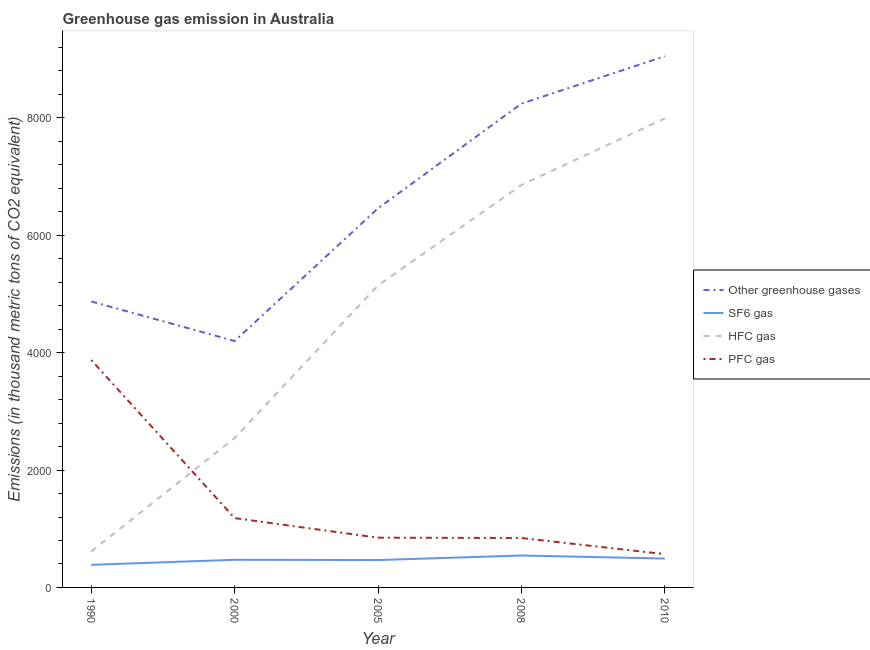Is the number of lines equal to the number of legend labels?
Ensure brevity in your answer.  Yes. What is the emission of greenhouse gases in 1990?
Your answer should be very brief. 4872.8. Across all years, what is the maximum emission of greenhouse gases?
Provide a succinct answer. 9051. Across all years, what is the minimum emission of greenhouse gases?
Provide a short and direct response. 4198.3. What is the total emission of greenhouse gases in the graph?
Your answer should be very brief. 3.28e+04. What is the difference between the emission of greenhouse gases in 1990 and that in 2008?
Your answer should be compact. -3370.7. What is the difference between the emission of sf6 gas in 2000 and the emission of pfc gas in 2010?
Provide a succinct answer. -95.8. What is the average emission of pfc gas per year?
Ensure brevity in your answer.  1462.6. In the year 2008, what is the difference between the emission of sf6 gas and emission of pfc gas?
Provide a short and direct response. -297.9. What is the ratio of the emission of greenhouse gases in 2008 to that in 2010?
Provide a succinct answer. 0.91. What is the difference between the highest and the second highest emission of sf6 gas?
Provide a succinct answer. 52.1. What is the difference between the highest and the lowest emission of hfc gas?
Ensure brevity in your answer.  7379.5. In how many years, is the emission of hfc gas greater than the average emission of hfc gas taken over all years?
Your answer should be compact. 3. Is it the case that in every year, the sum of the emission of greenhouse gases and emission of sf6 gas is greater than the sum of emission of hfc gas and emission of pfc gas?
Make the answer very short. No. Is it the case that in every year, the sum of the emission of greenhouse gases and emission of sf6 gas is greater than the emission of hfc gas?
Keep it short and to the point. Yes. How many lines are there?
Keep it short and to the point. 4. How many years are there in the graph?
Your answer should be very brief. 5. What is the difference between two consecutive major ticks on the Y-axis?
Give a very brief answer. 2000. Does the graph contain any zero values?
Your answer should be very brief. No. Does the graph contain grids?
Make the answer very short. No. What is the title of the graph?
Provide a succinct answer. Greenhouse gas emission in Australia. Does "Other greenhouse gases" appear as one of the legend labels in the graph?
Offer a very short reply. Yes. What is the label or title of the X-axis?
Provide a succinct answer. Year. What is the label or title of the Y-axis?
Provide a short and direct response. Emissions (in thousand metric tons of CO2 equivalent). What is the Emissions (in thousand metric tons of CO2 equivalent) in Other greenhouse gases in 1990?
Provide a succinct answer. 4872.8. What is the Emissions (in thousand metric tons of CO2 equivalent) of SF6 gas in 1990?
Provide a short and direct response. 385.1. What is the Emissions (in thousand metric tons of CO2 equivalent) of HFC gas in 1990?
Give a very brief answer. 612.5. What is the Emissions (in thousand metric tons of CO2 equivalent) of PFC gas in 1990?
Offer a very short reply. 3875.2. What is the Emissions (in thousand metric tons of CO2 equivalent) in Other greenhouse gases in 2000?
Give a very brief answer. 4198.3. What is the Emissions (in thousand metric tons of CO2 equivalent) of SF6 gas in 2000?
Ensure brevity in your answer.  471.2. What is the Emissions (in thousand metric tons of CO2 equivalent) in HFC gas in 2000?
Keep it short and to the point. 2545.7. What is the Emissions (in thousand metric tons of CO2 equivalent) in PFC gas in 2000?
Provide a short and direct response. 1181.4. What is the Emissions (in thousand metric tons of CO2 equivalent) of Other greenhouse gases in 2005?
Provide a succinct answer. 6459.6. What is the Emissions (in thousand metric tons of CO2 equivalent) of SF6 gas in 2005?
Offer a very short reply. 466.6. What is the Emissions (in thousand metric tons of CO2 equivalent) in HFC gas in 2005?
Ensure brevity in your answer.  5145.6. What is the Emissions (in thousand metric tons of CO2 equivalent) of PFC gas in 2005?
Ensure brevity in your answer.  847.4. What is the Emissions (in thousand metric tons of CO2 equivalent) of Other greenhouse gases in 2008?
Your answer should be compact. 8243.5. What is the Emissions (in thousand metric tons of CO2 equivalent) in SF6 gas in 2008?
Offer a terse response. 544.1. What is the Emissions (in thousand metric tons of CO2 equivalent) in HFC gas in 2008?
Ensure brevity in your answer.  6857.4. What is the Emissions (in thousand metric tons of CO2 equivalent) in PFC gas in 2008?
Provide a short and direct response. 842. What is the Emissions (in thousand metric tons of CO2 equivalent) of Other greenhouse gases in 2010?
Offer a terse response. 9051. What is the Emissions (in thousand metric tons of CO2 equivalent) of SF6 gas in 2010?
Keep it short and to the point. 492. What is the Emissions (in thousand metric tons of CO2 equivalent) of HFC gas in 2010?
Your answer should be very brief. 7992. What is the Emissions (in thousand metric tons of CO2 equivalent) of PFC gas in 2010?
Give a very brief answer. 567. Across all years, what is the maximum Emissions (in thousand metric tons of CO2 equivalent) in Other greenhouse gases?
Offer a very short reply. 9051. Across all years, what is the maximum Emissions (in thousand metric tons of CO2 equivalent) in SF6 gas?
Offer a very short reply. 544.1. Across all years, what is the maximum Emissions (in thousand metric tons of CO2 equivalent) of HFC gas?
Give a very brief answer. 7992. Across all years, what is the maximum Emissions (in thousand metric tons of CO2 equivalent) in PFC gas?
Provide a succinct answer. 3875.2. Across all years, what is the minimum Emissions (in thousand metric tons of CO2 equivalent) of Other greenhouse gases?
Make the answer very short. 4198.3. Across all years, what is the minimum Emissions (in thousand metric tons of CO2 equivalent) of SF6 gas?
Your response must be concise. 385.1. Across all years, what is the minimum Emissions (in thousand metric tons of CO2 equivalent) in HFC gas?
Provide a succinct answer. 612.5. Across all years, what is the minimum Emissions (in thousand metric tons of CO2 equivalent) of PFC gas?
Make the answer very short. 567. What is the total Emissions (in thousand metric tons of CO2 equivalent) in Other greenhouse gases in the graph?
Keep it short and to the point. 3.28e+04. What is the total Emissions (in thousand metric tons of CO2 equivalent) of SF6 gas in the graph?
Keep it short and to the point. 2359. What is the total Emissions (in thousand metric tons of CO2 equivalent) of HFC gas in the graph?
Keep it short and to the point. 2.32e+04. What is the total Emissions (in thousand metric tons of CO2 equivalent) of PFC gas in the graph?
Ensure brevity in your answer.  7313. What is the difference between the Emissions (in thousand metric tons of CO2 equivalent) of Other greenhouse gases in 1990 and that in 2000?
Give a very brief answer. 674.5. What is the difference between the Emissions (in thousand metric tons of CO2 equivalent) of SF6 gas in 1990 and that in 2000?
Provide a succinct answer. -86.1. What is the difference between the Emissions (in thousand metric tons of CO2 equivalent) in HFC gas in 1990 and that in 2000?
Give a very brief answer. -1933.2. What is the difference between the Emissions (in thousand metric tons of CO2 equivalent) in PFC gas in 1990 and that in 2000?
Your answer should be very brief. 2693.8. What is the difference between the Emissions (in thousand metric tons of CO2 equivalent) in Other greenhouse gases in 1990 and that in 2005?
Your response must be concise. -1586.8. What is the difference between the Emissions (in thousand metric tons of CO2 equivalent) of SF6 gas in 1990 and that in 2005?
Ensure brevity in your answer.  -81.5. What is the difference between the Emissions (in thousand metric tons of CO2 equivalent) of HFC gas in 1990 and that in 2005?
Give a very brief answer. -4533.1. What is the difference between the Emissions (in thousand metric tons of CO2 equivalent) of PFC gas in 1990 and that in 2005?
Ensure brevity in your answer.  3027.8. What is the difference between the Emissions (in thousand metric tons of CO2 equivalent) of Other greenhouse gases in 1990 and that in 2008?
Provide a short and direct response. -3370.7. What is the difference between the Emissions (in thousand metric tons of CO2 equivalent) in SF6 gas in 1990 and that in 2008?
Your answer should be very brief. -159. What is the difference between the Emissions (in thousand metric tons of CO2 equivalent) in HFC gas in 1990 and that in 2008?
Provide a succinct answer. -6244.9. What is the difference between the Emissions (in thousand metric tons of CO2 equivalent) in PFC gas in 1990 and that in 2008?
Ensure brevity in your answer.  3033.2. What is the difference between the Emissions (in thousand metric tons of CO2 equivalent) in Other greenhouse gases in 1990 and that in 2010?
Offer a terse response. -4178.2. What is the difference between the Emissions (in thousand metric tons of CO2 equivalent) in SF6 gas in 1990 and that in 2010?
Make the answer very short. -106.9. What is the difference between the Emissions (in thousand metric tons of CO2 equivalent) in HFC gas in 1990 and that in 2010?
Your response must be concise. -7379.5. What is the difference between the Emissions (in thousand metric tons of CO2 equivalent) of PFC gas in 1990 and that in 2010?
Give a very brief answer. 3308.2. What is the difference between the Emissions (in thousand metric tons of CO2 equivalent) of Other greenhouse gases in 2000 and that in 2005?
Your answer should be compact. -2261.3. What is the difference between the Emissions (in thousand metric tons of CO2 equivalent) in SF6 gas in 2000 and that in 2005?
Your answer should be compact. 4.6. What is the difference between the Emissions (in thousand metric tons of CO2 equivalent) of HFC gas in 2000 and that in 2005?
Provide a short and direct response. -2599.9. What is the difference between the Emissions (in thousand metric tons of CO2 equivalent) in PFC gas in 2000 and that in 2005?
Provide a succinct answer. 334. What is the difference between the Emissions (in thousand metric tons of CO2 equivalent) of Other greenhouse gases in 2000 and that in 2008?
Your response must be concise. -4045.2. What is the difference between the Emissions (in thousand metric tons of CO2 equivalent) of SF6 gas in 2000 and that in 2008?
Make the answer very short. -72.9. What is the difference between the Emissions (in thousand metric tons of CO2 equivalent) in HFC gas in 2000 and that in 2008?
Offer a terse response. -4311.7. What is the difference between the Emissions (in thousand metric tons of CO2 equivalent) of PFC gas in 2000 and that in 2008?
Provide a short and direct response. 339.4. What is the difference between the Emissions (in thousand metric tons of CO2 equivalent) of Other greenhouse gases in 2000 and that in 2010?
Ensure brevity in your answer.  -4852.7. What is the difference between the Emissions (in thousand metric tons of CO2 equivalent) of SF6 gas in 2000 and that in 2010?
Ensure brevity in your answer.  -20.8. What is the difference between the Emissions (in thousand metric tons of CO2 equivalent) in HFC gas in 2000 and that in 2010?
Offer a very short reply. -5446.3. What is the difference between the Emissions (in thousand metric tons of CO2 equivalent) of PFC gas in 2000 and that in 2010?
Your answer should be very brief. 614.4. What is the difference between the Emissions (in thousand metric tons of CO2 equivalent) in Other greenhouse gases in 2005 and that in 2008?
Provide a succinct answer. -1783.9. What is the difference between the Emissions (in thousand metric tons of CO2 equivalent) of SF6 gas in 2005 and that in 2008?
Offer a very short reply. -77.5. What is the difference between the Emissions (in thousand metric tons of CO2 equivalent) in HFC gas in 2005 and that in 2008?
Offer a terse response. -1711.8. What is the difference between the Emissions (in thousand metric tons of CO2 equivalent) of Other greenhouse gases in 2005 and that in 2010?
Ensure brevity in your answer.  -2591.4. What is the difference between the Emissions (in thousand metric tons of CO2 equivalent) of SF6 gas in 2005 and that in 2010?
Provide a short and direct response. -25.4. What is the difference between the Emissions (in thousand metric tons of CO2 equivalent) in HFC gas in 2005 and that in 2010?
Make the answer very short. -2846.4. What is the difference between the Emissions (in thousand metric tons of CO2 equivalent) in PFC gas in 2005 and that in 2010?
Give a very brief answer. 280.4. What is the difference between the Emissions (in thousand metric tons of CO2 equivalent) of Other greenhouse gases in 2008 and that in 2010?
Provide a succinct answer. -807.5. What is the difference between the Emissions (in thousand metric tons of CO2 equivalent) of SF6 gas in 2008 and that in 2010?
Offer a terse response. 52.1. What is the difference between the Emissions (in thousand metric tons of CO2 equivalent) of HFC gas in 2008 and that in 2010?
Offer a terse response. -1134.6. What is the difference between the Emissions (in thousand metric tons of CO2 equivalent) of PFC gas in 2008 and that in 2010?
Provide a succinct answer. 275. What is the difference between the Emissions (in thousand metric tons of CO2 equivalent) in Other greenhouse gases in 1990 and the Emissions (in thousand metric tons of CO2 equivalent) in SF6 gas in 2000?
Your answer should be very brief. 4401.6. What is the difference between the Emissions (in thousand metric tons of CO2 equivalent) in Other greenhouse gases in 1990 and the Emissions (in thousand metric tons of CO2 equivalent) in HFC gas in 2000?
Provide a short and direct response. 2327.1. What is the difference between the Emissions (in thousand metric tons of CO2 equivalent) of Other greenhouse gases in 1990 and the Emissions (in thousand metric tons of CO2 equivalent) of PFC gas in 2000?
Offer a terse response. 3691.4. What is the difference between the Emissions (in thousand metric tons of CO2 equivalent) of SF6 gas in 1990 and the Emissions (in thousand metric tons of CO2 equivalent) of HFC gas in 2000?
Ensure brevity in your answer.  -2160.6. What is the difference between the Emissions (in thousand metric tons of CO2 equivalent) in SF6 gas in 1990 and the Emissions (in thousand metric tons of CO2 equivalent) in PFC gas in 2000?
Give a very brief answer. -796.3. What is the difference between the Emissions (in thousand metric tons of CO2 equivalent) of HFC gas in 1990 and the Emissions (in thousand metric tons of CO2 equivalent) of PFC gas in 2000?
Provide a succinct answer. -568.9. What is the difference between the Emissions (in thousand metric tons of CO2 equivalent) in Other greenhouse gases in 1990 and the Emissions (in thousand metric tons of CO2 equivalent) in SF6 gas in 2005?
Keep it short and to the point. 4406.2. What is the difference between the Emissions (in thousand metric tons of CO2 equivalent) in Other greenhouse gases in 1990 and the Emissions (in thousand metric tons of CO2 equivalent) in HFC gas in 2005?
Give a very brief answer. -272.8. What is the difference between the Emissions (in thousand metric tons of CO2 equivalent) in Other greenhouse gases in 1990 and the Emissions (in thousand metric tons of CO2 equivalent) in PFC gas in 2005?
Your answer should be compact. 4025.4. What is the difference between the Emissions (in thousand metric tons of CO2 equivalent) in SF6 gas in 1990 and the Emissions (in thousand metric tons of CO2 equivalent) in HFC gas in 2005?
Your answer should be compact. -4760.5. What is the difference between the Emissions (in thousand metric tons of CO2 equivalent) in SF6 gas in 1990 and the Emissions (in thousand metric tons of CO2 equivalent) in PFC gas in 2005?
Offer a terse response. -462.3. What is the difference between the Emissions (in thousand metric tons of CO2 equivalent) of HFC gas in 1990 and the Emissions (in thousand metric tons of CO2 equivalent) of PFC gas in 2005?
Make the answer very short. -234.9. What is the difference between the Emissions (in thousand metric tons of CO2 equivalent) of Other greenhouse gases in 1990 and the Emissions (in thousand metric tons of CO2 equivalent) of SF6 gas in 2008?
Your answer should be compact. 4328.7. What is the difference between the Emissions (in thousand metric tons of CO2 equivalent) in Other greenhouse gases in 1990 and the Emissions (in thousand metric tons of CO2 equivalent) in HFC gas in 2008?
Offer a very short reply. -1984.6. What is the difference between the Emissions (in thousand metric tons of CO2 equivalent) of Other greenhouse gases in 1990 and the Emissions (in thousand metric tons of CO2 equivalent) of PFC gas in 2008?
Your answer should be compact. 4030.8. What is the difference between the Emissions (in thousand metric tons of CO2 equivalent) in SF6 gas in 1990 and the Emissions (in thousand metric tons of CO2 equivalent) in HFC gas in 2008?
Keep it short and to the point. -6472.3. What is the difference between the Emissions (in thousand metric tons of CO2 equivalent) of SF6 gas in 1990 and the Emissions (in thousand metric tons of CO2 equivalent) of PFC gas in 2008?
Provide a succinct answer. -456.9. What is the difference between the Emissions (in thousand metric tons of CO2 equivalent) of HFC gas in 1990 and the Emissions (in thousand metric tons of CO2 equivalent) of PFC gas in 2008?
Provide a short and direct response. -229.5. What is the difference between the Emissions (in thousand metric tons of CO2 equivalent) in Other greenhouse gases in 1990 and the Emissions (in thousand metric tons of CO2 equivalent) in SF6 gas in 2010?
Give a very brief answer. 4380.8. What is the difference between the Emissions (in thousand metric tons of CO2 equivalent) of Other greenhouse gases in 1990 and the Emissions (in thousand metric tons of CO2 equivalent) of HFC gas in 2010?
Offer a very short reply. -3119.2. What is the difference between the Emissions (in thousand metric tons of CO2 equivalent) in Other greenhouse gases in 1990 and the Emissions (in thousand metric tons of CO2 equivalent) in PFC gas in 2010?
Make the answer very short. 4305.8. What is the difference between the Emissions (in thousand metric tons of CO2 equivalent) in SF6 gas in 1990 and the Emissions (in thousand metric tons of CO2 equivalent) in HFC gas in 2010?
Give a very brief answer. -7606.9. What is the difference between the Emissions (in thousand metric tons of CO2 equivalent) in SF6 gas in 1990 and the Emissions (in thousand metric tons of CO2 equivalent) in PFC gas in 2010?
Make the answer very short. -181.9. What is the difference between the Emissions (in thousand metric tons of CO2 equivalent) in HFC gas in 1990 and the Emissions (in thousand metric tons of CO2 equivalent) in PFC gas in 2010?
Your answer should be compact. 45.5. What is the difference between the Emissions (in thousand metric tons of CO2 equivalent) of Other greenhouse gases in 2000 and the Emissions (in thousand metric tons of CO2 equivalent) of SF6 gas in 2005?
Your response must be concise. 3731.7. What is the difference between the Emissions (in thousand metric tons of CO2 equivalent) of Other greenhouse gases in 2000 and the Emissions (in thousand metric tons of CO2 equivalent) of HFC gas in 2005?
Provide a short and direct response. -947.3. What is the difference between the Emissions (in thousand metric tons of CO2 equivalent) of Other greenhouse gases in 2000 and the Emissions (in thousand metric tons of CO2 equivalent) of PFC gas in 2005?
Provide a short and direct response. 3350.9. What is the difference between the Emissions (in thousand metric tons of CO2 equivalent) of SF6 gas in 2000 and the Emissions (in thousand metric tons of CO2 equivalent) of HFC gas in 2005?
Provide a short and direct response. -4674.4. What is the difference between the Emissions (in thousand metric tons of CO2 equivalent) in SF6 gas in 2000 and the Emissions (in thousand metric tons of CO2 equivalent) in PFC gas in 2005?
Ensure brevity in your answer.  -376.2. What is the difference between the Emissions (in thousand metric tons of CO2 equivalent) of HFC gas in 2000 and the Emissions (in thousand metric tons of CO2 equivalent) of PFC gas in 2005?
Provide a succinct answer. 1698.3. What is the difference between the Emissions (in thousand metric tons of CO2 equivalent) of Other greenhouse gases in 2000 and the Emissions (in thousand metric tons of CO2 equivalent) of SF6 gas in 2008?
Your answer should be very brief. 3654.2. What is the difference between the Emissions (in thousand metric tons of CO2 equivalent) in Other greenhouse gases in 2000 and the Emissions (in thousand metric tons of CO2 equivalent) in HFC gas in 2008?
Offer a terse response. -2659.1. What is the difference between the Emissions (in thousand metric tons of CO2 equivalent) of Other greenhouse gases in 2000 and the Emissions (in thousand metric tons of CO2 equivalent) of PFC gas in 2008?
Make the answer very short. 3356.3. What is the difference between the Emissions (in thousand metric tons of CO2 equivalent) of SF6 gas in 2000 and the Emissions (in thousand metric tons of CO2 equivalent) of HFC gas in 2008?
Your answer should be compact. -6386.2. What is the difference between the Emissions (in thousand metric tons of CO2 equivalent) in SF6 gas in 2000 and the Emissions (in thousand metric tons of CO2 equivalent) in PFC gas in 2008?
Provide a succinct answer. -370.8. What is the difference between the Emissions (in thousand metric tons of CO2 equivalent) of HFC gas in 2000 and the Emissions (in thousand metric tons of CO2 equivalent) of PFC gas in 2008?
Offer a terse response. 1703.7. What is the difference between the Emissions (in thousand metric tons of CO2 equivalent) of Other greenhouse gases in 2000 and the Emissions (in thousand metric tons of CO2 equivalent) of SF6 gas in 2010?
Provide a short and direct response. 3706.3. What is the difference between the Emissions (in thousand metric tons of CO2 equivalent) in Other greenhouse gases in 2000 and the Emissions (in thousand metric tons of CO2 equivalent) in HFC gas in 2010?
Your response must be concise. -3793.7. What is the difference between the Emissions (in thousand metric tons of CO2 equivalent) of Other greenhouse gases in 2000 and the Emissions (in thousand metric tons of CO2 equivalent) of PFC gas in 2010?
Your answer should be very brief. 3631.3. What is the difference between the Emissions (in thousand metric tons of CO2 equivalent) in SF6 gas in 2000 and the Emissions (in thousand metric tons of CO2 equivalent) in HFC gas in 2010?
Your answer should be compact. -7520.8. What is the difference between the Emissions (in thousand metric tons of CO2 equivalent) of SF6 gas in 2000 and the Emissions (in thousand metric tons of CO2 equivalent) of PFC gas in 2010?
Offer a very short reply. -95.8. What is the difference between the Emissions (in thousand metric tons of CO2 equivalent) in HFC gas in 2000 and the Emissions (in thousand metric tons of CO2 equivalent) in PFC gas in 2010?
Provide a succinct answer. 1978.7. What is the difference between the Emissions (in thousand metric tons of CO2 equivalent) of Other greenhouse gases in 2005 and the Emissions (in thousand metric tons of CO2 equivalent) of SF6 gas in 2008?
Give a very brief answer. 5915.5. What is the difference between the Emissions (in thousand metric tons of CO2 equivalent) of Other greenhouse gases in 2005 and the Emissions (in thousand metric tons of CO2 equivalent) of HFC gas in 2008?
Provide a succinct answer. -397.8. What is the difference between the Emissions (in thousand metric tons of CO2 equivalent) in Other greenhouse gases in 2005 and the Emissions (in thousand metric tons of CO2 equivalent) in PFC gas in 2008?
Provide a succinct answer. 5617.6. What is the difference between the Emissions (in thousand metric tons of CO2 equivalent) of SF6 gas in 2005 and the Emissions (in thousand metric tons of CO2 equivalent) of HFC gas in 2008?
Your answer should be very brief. -6390.8. What is the difference between the Emissions (in thousand metric tons of CO2 equivalent) of SF6 gas in 2005 and the Emissions (in thousand metric tons of CO2 equivalent) of PFC gas in 2008?
Keep it short and to the point. -375.4. What is the difference between the Emissions (in thousand metric tons of CO2 equivalent) in HFC gas in 2005 and the Emissions (in thousand metric tons of CO2 equivalent) in PFC gas in 2008?
Your response must be concise. 4303.6. What is the difference between the Emissions (in thousand metric tons of CO2 equivalent) in Other greenhouse gases in 2005 and the Emissions (in thousand metric tons of CO2 equivalent) in SF6 gas in 2010?
Provide a short and direct response. 5967.6. What is the difference between the Emissions (in thousand metric tons of CO2 equivalent) of Other greenhouse gases in 2005 and the Emissions (in thousand metric tons of CO2 equivalent) of HFC gas in 2010?
Your answer should be compact. -1532.4. What is the difference between the Emissions (in thousand metric tons of CO2 equivalent) in Other greenhouse gases in 2005 and the Emissions (in thousand metric tons of CO2 equivalent) in PFC gas in 2010?
Make the answer very short. 5892.6. What is the difference between the Emissions (in thousand metric tons of CO2 equivalent) of SF6 gas in 2005 and the Emissions (in thousand metric tons of CO2 equivalent) of HFC gas in 2010?
Your response must be concise. -7525.4. What is the difference between the Emissions (in thousand metric tons of CO2 equivalent) of SF6 gas in 2005 and the Emissions (in thousand metric tons of CO2 equivalent) of PFC gas in 2010?
Provide a succinct answer. -100.4. What is the difference between the Emissions (in thousand metric tons of CO2 equivalent) of HFC gas in 2005 and the Emissions (in thousand metric tons of CO2 equivalent) of PFC gas in 2010?
Provide a short and direct response. 4578.6. What is the difference between the Emissions (in thousand metric tons of CO2 equivalent) in Other greenhouse gases in 2008 and the Emissions (in thousand metric tons of CO2 equivalent) in SF6 gas in 2010?
Offer a terse response. 7751.5. What is the difference between the Emissions (in thousand metric tons of CO2 equivalent) in Other greenhouse gases in 2008 and the Emissions (in thousand metric tons of CO2 equivalent) in HFC gas in 2010?
Offer a terse response. 251.5. What is the difference between the Emissions (in thousand metric tons of CO2 equivalent) of Other greenhouse gases in 2008 and the Emissions (in thousand metric tons of CO2 equivalent) of PFC gas in 2010?
Offer a very short reply. 7676.5. What is the difference between the Emissions (in thousand metric tons of CO2 equivalent) in SF6 gas in 2008 and the Emissions (in thousand metric tons of CO2 equivalent) in HFC gas in 2010?
Your answer should be compact. -7447.9. What is the difference between the Emissions (in thousand metric tons of CO2 equivalent) in SF6 gas in 2008 and the Emissions (in thousand metric tons of CO2 equivalent) in PFC gas in 2010?
Provide a short and direct response. -22.9. What is the difference between the Emissions (in thousand metric tons of CO2 equivalent) in HFC gas in 2008 and the Emissions (in thousand metric tons of CO2 equivalent) in PFC gas in 2010?
Provide a succinct answer. 6290.4. What is the average Emissions (in thousand metric tons of CO2 equivalent) in Other greenhouse gases per year?
Make the answer very short. 6565.04. What is the average Emissions (in thousand metric tons of CO2 equivalent) in SF6 gas per year?
Your answer should be very brief. 471.8. What is the average Emissions (in thousand metric tons of CO2 equivalent) in HFC gas per year?
Give a very brief answer. 4630.64. What is the average Emissions (in thousand metric tons of CO2 equivalent) of PFC gas per year?
Provide a succinct answer. 1462.6. In the year 1990, what is the difference between the Emissions (in thousand metric tons of CO2 equivalent) of Other greenhouse gases and Emissions (in thousand metric tons of CO2 equivalent) of SF6 gas?
Your answer should be very brief. 4487.7. In the year 1990, what is the difference between the Emissions (in thousand metric tons of CO2 equivalent) in Other greenhouse gases and Emissions (in thousand metric tons of CO2 equivalent) in HFC gas?
Make the answer very short. 4260.3. In the year 1990, what is the difference between the Emissions (in thousand metric tons of CO2 equivalent) in Other greenhouse gases and Emissions (in thousand metric tons of CO2 equivalent) in PFC gas?
Offer a very short reply. 997.6. In the year 1990, what is the difference between the Emissions (in thousand metric tons of CO2 equivalent) in SF6 gas and Emissions (in thousand metric tons of CO2 equivalent) in HFC gas?
Make the answer very short. -227.4. In the year 1990, what is the difference between the Emissions (in thousand metric tons of CO2 equivalent) in SF6 gas and Emissions (in thousand metric tons of CO2 equivalent) in PFC gas?
Your answer should be compact. -3490.1. In the year 1990, what is the difference between the Emissions (in thousand metric tons of CO2 equivalent) in HFC gas and Emissions (in thousand metric tons of CO2 equivalent) in PFC gas?
Offer a terse response. -3262.7. In the year 2000, what is the difference between the Emissions (in thousand metric tons of CO2 equivalent) in Other greenhouse gases and Emissions (in thousand metric tons of CO2 equivalent) in SF6 gas?
Offer a terse response. 3727.1. In the year 2000, what is the difference between the Emissions (in thousand metric tons of CO2 equivalent) in Other greenhouse gases and Emissions (in thousand metric tons of CO2 equivalent) in HFC gas?
Offer a terse response. 1652.6. In the year 2000, what is the difference between the Emissions (in thousand metric tons of CO2 equivalent) of Other greenhouse gases and Emissions (in thousand metric tons of CO2 equivalent) of PFC gas?
Make the answer very short. 3016.9. In the year 2000, what is the difference between the Emissions (in thousand metric tons of CO2 equivalent) of SF6 gas and Emissions (in thousand metric tons of CO2 equivalent) of HFC gas?
Provide a short and direct response. -2074.5. In the year 2000, what is the difference between the Emissions (in thousand metric tons of CO2 equivalent) in SF6 gas and Emissions (in thousand metric tons of CO2 equivalent) in PFC gas?
Give a very brief answer. -710.2. In the year 2000, what is the difference between the Emissions (in thousand metric tons of CO2 equivalent) in HFC gas and Emissions (in thousand metric tons of CO2 equivalent) in PFC gas?
Offer a terse response. 1364.3. In the year 2005, what is the difference between the Emissions (in thousand metric tons of CO2 equivalent) in Other greenhouse gases and Emissions (in thousand metric tons of CO2 equivalent) in SF6 gas?
Your answer should be compact. 5993. In the year 2005, what is the difference between the Emissions (in thousand metric tons of CO2 equivalent) of Other greenhouse gases and Emissions (in thousand metric tons of CO2 equivalent) of HFC gas?
Your response must be concise. 1314. In the year 2005, what is the difference between the Emissions (in thousand metric tons of CO2 equivalent) in Other greenhouse gases and Emissions (in thousand metric tons of CO2 equivalent) in PFC gas?
Offer a very short reply. 5612.2. In the year 2005, what is the difference between the Emissions (in thousand metric tons of CO2 equivalent) of SF6 gas and Emissions (in thousand metric tons of CO2 equivalent) of HFC gas?
Ensure brevity in your answer.  -4679. In the year 2005, what is the difference between the Emissions (in thousand metric tons of CO2 equivalent) in SF6 gas and Emissions (in thousand metric tons of CO2 equivalent) in PFC gas?
Keep it short and to the point. -380.8. In the year 2005, what is the difference between the Emissions (in thousand metric tons of CO2 equivalent) in HFC gas and Emissions (in thousand metric tons of CO2 equivalent) in PFC gas?
Provide a short and direct response. 4298.2. In the year 2008, what is the difference between the Emissions (in thousand metric tons of CO2 equivalent) in Other greenhouse gases and Emissions (in thousand metric tons of CO2 equivalent) in SF6 gas?
Keep it short and to the point. 7699.4. In the year 2008, what is the difference between the Emissions (in thousand metric tons of CO2 equivalent) of Other greenhouse gases and Emissions (in thousand metric tons of CO2 equivalent) of HFC gas?
Your answer should be compact. 1386.1. In the year 2008, what is the difference between the Emissions (in thousand metric tons of CO2 equivalent) in Other greenhouse gases and Emissions (in thousand metric tons of CO2 equivalent) in PFC gas?
Provide a short and direct response. 7401.5. In the year 2008, what is the difference between the Emissions (in thousand metric tons of CO2 equivalent) of SF6 gas and Emissions (in thousand metric tons of CO2 equivalent) of HFC gas?
Ensure brevity in your answer.  -6313.3. In the year 2008, what is the difference between the Emissions (in thousand metric tons of CO2 equivalent) of SF6 gas and Emissions (in thousand metric tons of CO2 equivalent) of PFC gas?
Provide a short and direct response. -297.9. In the year 2008, what is the difference between the Emissions (in thousand metric tons of CO2 equivalent) in HFC gas and Emissions (in thousand metric tons of CO2 equivalent) in PFC gas?
Provide a succinct answer. 6015.4. In the year 2010, what is the difference between the Emissions (in thousand metric tons of CO2 equivalent) of Other greenhouse gases and Emissions (in thousand metric tons of CO2 equivalent) of SF6 gas?
Provide a short and direct response. 8559. In the year 2010, what is the difference between the Emissions (in thousand metric tons of CO2 equivalent) in Other greenhouse gases and Emissions (in thousand metric tons of CO2 equivalent) in HFC gas?
Give a very brief answer. 1059. In the year 2010, what is the difference between the Emissions (in thousand metric tons of CO2 equivalent) in Other greenhouse gases and Emissions (in thousand metric tons of CO2 equivalent) in PFC gas?
Give a very brief answer. 8484. In the year 2010, what is the difference between the Emissions (in thousand metric tons of CO2 equivalent) of SF6 gas and Emissions (in thousand metric tons of CO2 equivalent) of HFC gas?
Provide a succinct answer. -7500. In the year 2010, what is the difference between the Emissions (in thousand metric tons of CO2 equivalent) in SF6 gas and Emissions (in thousand metric tons of CO2 equivalent) in PFC gas?
Offer a terse response. -75. In the year 2010, what is the difference between the Emissions (in thousand metric tons of CO2 equivalent) of HFC gas and Emissions (in thousand metric tons of CO2 equivalent) of PFC gas?
Your response must be concise. 7425. What is the ratio of the Emissions (in thousand metric tons of CO2 equivalent) in Other greenhouse gases in 1990 to that in 2000?
Provide a short and direct response. 1.16. What is the ratio of the Emissions (in thousand metric tons of CO2 equivalent) in SF6 gas in 1990 to that in 2000?
Make the answer very short. 0.82. What is the ratio of the Emissions (in thousand metric tons of CO2 equivalent) of HFC gas in 1990 to that in 2000?
Give a very brief answer. 0.24. What is the ratio of the Emissions (in thousand metric tons of CO2 equivalent) of PFC gas in 1990 to that in 2000?
Your response must be concise. 3.28. What is the ratio of the Emissions (in thousand metric tons of CO2 equivalent) in Other greenhouse gases in 1990 to that in 2005?
Keep it short and to the point. 0.75. What is the ratio of the Emissions (in thousand metric tons of CO2 equivalent) of SF6 gas in 1990 to that in 2005?
Make the answer very short. 0.83. What is the ratio of the Emissions (in thousand metric tons of CO2 equivalent) of HFC gas in 1990 to that in 2005?
Provide a short and direct response. 0.12. What is the ratio of the Emissions (in thousand metric tons of CO2 equivalent) of PFC gas in 1990 to that in 2005?
Your answer should be compact. 4.57. What is the ratio of the Emissions (in thousand metric tons of CO2 equivalent) in Other greenhouse gases in 1990 to that in 2008?
Keep it short and to the point. 0.59. What is the ratio of the Emissions (in thousand metric tons of CO2 equivalent) in SF6 gas in 1990 to that in 2008?
Your answer should be compact. 0.71. What is the ratio of the Emissions (in thousand metric tons of CO2 equivalent) in HFC gas in 1990 to that in 2008?
Offer a very short reply. 0.09. What is the ratio of the Emissions (in thousand metric tons of CO2 equivalent) of PFC gas in 1990 to that in 2008?
Keep it short and to the point. 4.6. What is the ratio of the Emissions (in thousand metric tons of CO2 equivalent) of Other greenhouse gases in 1990 to that in 2010?
Make the answer very short. 0.54. What is the ratio of the Emissions (in thousand metric tons of CO2 equivalent) of SF6 gas in 1990 to that in 2010?
Ensure brevity in your answer.  0.78. What is the ratio of the Emissions (in thousand metric tons of CO2 equivalent) of HFC gas in 1990 to that in 2010?
Your answer should be very brief. 0.08. What is the ratio of the Emissions (in thousand metric tons of CO2 equivalent) in PFC gas in 1990 to that in 2010?
Provide a succinct answer. 6.83. What is the ratio of the Emissions (in thousand metric tons of CO2 equivalent) of Other greenhouse gases in 2000 to that in 2005?
Give a very brief answer. 0.65. What is the ratio of the Emissions (in thousand metric tons of CO2 equivalent) in SF6 gas in 2000 to that in 2005?
Your answer should be very brief. 1.01. What is the ratio of the Emissions (in thousand metric tons of CO2 equivalent) in HFC gas in 2000 to that in 2005?
Your answer should be compact. 0.49. What is the ratio of the Emissions (in thousand metric tons of CO2 equivalent) of PFC gas in 2000 to that in 2005?
Ensure brevity in your answer.  1.39. What is the ratio of the Emissions (in thousand metric tons of CO2 equivalent) of Other greenhouse gases in 2000 to that in 2008?
Your answer should be very brief. 0.51. What is the ratio of the Emissions (in thousand metric tons of CO2 equivalent) of SF6 gas in 2000 to that in 2008?
Make the answer very short. 0.87. What is the ratio of the Emissions (in thousand metric tons of CO2 equivalent) of HFC gas in 2000 to that in 2008?
Offer a terse response. 0.37. What is the ratio of the Emissions (in thousand metric tons of CO2 equivalent) of PFC gas in 2000 to that in 2008?
Provide a short and direct response. 1.4. What is the ratio of the Emissions (in thousand metric tons of CO2 equivalent) in Other greenhouse gases in 2000 to that in 2010?
Your answer should be very brief. 0.46. What is the ratio of the Emissions (in thousand metric tons of CO2 equivalent) of SF6 gas in 2000 to that in 2010?
Make the answer very short. 0.96. What is the ratio of the Emissions (in thousand metric tons of CO2 equivalent) in HFC gas in 2000 to that in 2010?
Make the answer very short. 0.32. What is the ratio of the Emissions (in thousand metric tons of CO2 equivalent) of PFC gas in 2000 to that in 2010?
Your answer should be very brief. 2.08. What is the ratio of the Emissions (in thousand metric tons of CO2 equivalent) in Other greenhouse gases in 2005 to that in 2008?
Offer a very short reply. 0.78. What is the ratio of the Emissions (in thousand metric tons of CO2 equivalent) in SF6 gas in 2005 to that in 2008?
Provide a succinct answer. 0.86. What is the ratio of the Emissions (in thousand metric tons of CO2 equivalent) of HFC gas in 2005 to that in 2008?
Ensure brevity in your answer.  0.75. What is the ratio of the Emissions (in thousand metric tons of CO2 equivalent) of PFC gas in 2005 to that in 2008?
Your answer should be compact. 1.01. What is the ratio of the Emissions (in thousand metric tons of CO2 equivalent) of Other greenhouse gases in 2005 to that in 2010?
Offer a terse response. 0.71. What is the ratio of the Emissions (in thousand metric tons of CO2 equivalent) of SF6 gas in 2005 to that in 2010?
Offer a very short reply. 0.95. What is the ratio of the Emissions (in thousand metric tons of CO2 equivalent) in HFC gas in 2005 to that in 2010?
Offer a terse response. 0.64. What is the ratio of the Emissions (in thousand metric tons of CO2 equivalent) of PFC gas in 2005 to that in 2010?
Offer a very short reply. 1.49. What is the ratio of the Emissions (in thousand metric tons of CO2 equivalent) in Other greenhouse gases in 2008 to that in 2010?
Provide a succinct answer. 0.91. What is the ratio of the Emissions (in thousand metric tons of CO2 equivalent) in SF6 gas in 2008 to that in 2010?
Your answer should be compact. 1.11. What is the ratio of the Emissions (in thousand metric tons of CO2 equivalent) of HFC gas in 2008 to that in 2010?
Offer a very short reply. 0.86. What is the ratio of the Emissions (in thousand metric tons of CO2 equivalent) in PFC gas in 2008 to that in 2010?
Ensure brevity in your answer.  1.49. What is the difference between the highest and the second highest Emissions (in thousand metric tons of CO2 equivalent) in Other greenhouse gases?
Provide a succinct answer. 807.5. What is the difference between the highest and the second highest Emissions (in thousand metric tons of CO2 equivalent) in SF6 gas?
Give a very brief answer. 52.1. What is the difference between the highest and the second highest Emissions (in thousand metric tons of CO2 equivalent) of HFC gas?
Offer a terse response. 1134.6. What is the difference between the highest and the second highest Emissions (in thousand metric tons of CO2 equivalent) of PFC gas?
Make the answer very short. 2693.8. What is the difference between the highest and the lowest Emissions (in thousand metric tons of CO2 equivalent) in Other greenhouse gases?
Provide a succinct answer. 4852.7. What is the difference between the highest and the lowest Emissions (in thousand metric tons of CO2 equivalent) in SF6 gas?
Your response must be concise. 159. What is the difference between the highest and the lowest Emissions (in thousand metric tons of CO2 equivalent) in HFC gas?
Give a very brief answer. 7379.5. What is the difference between the highest and the lowest Emissions (in thousand metric tons of CO2 equivalent) in PFC gas?
Provide a succinct answer. 3308.2. 